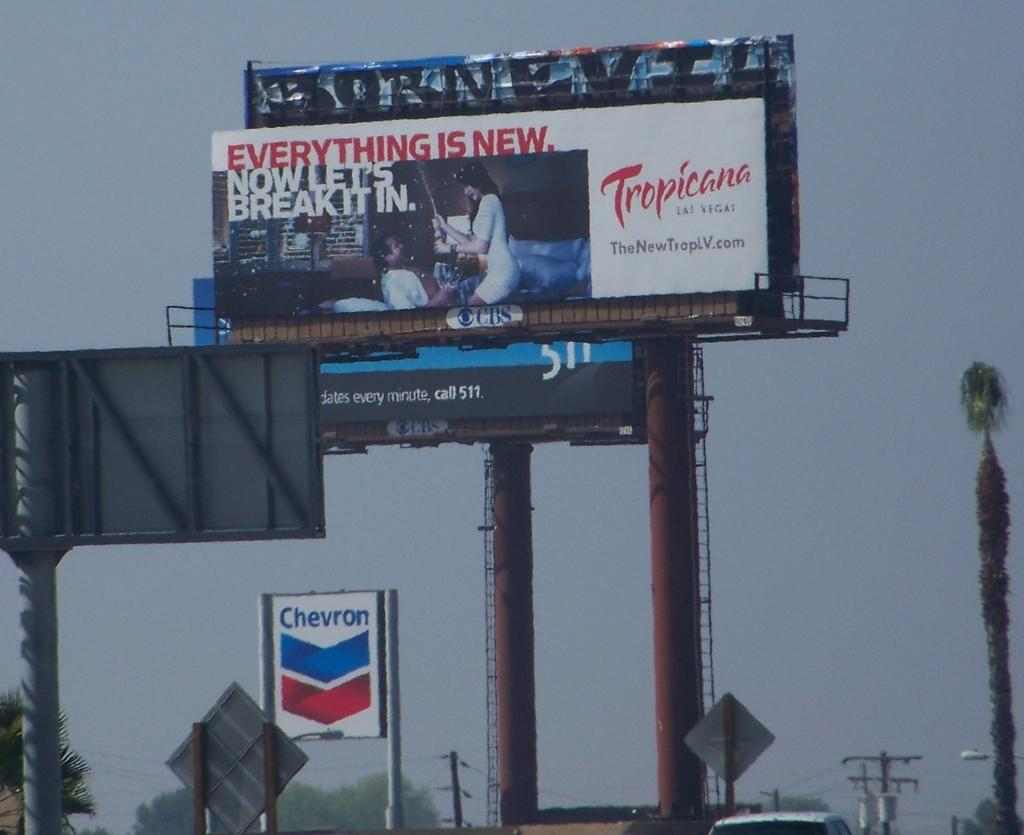Provide a one-sentence caption for the provided image. A billboard with an add for the Tropicana Hotel. 